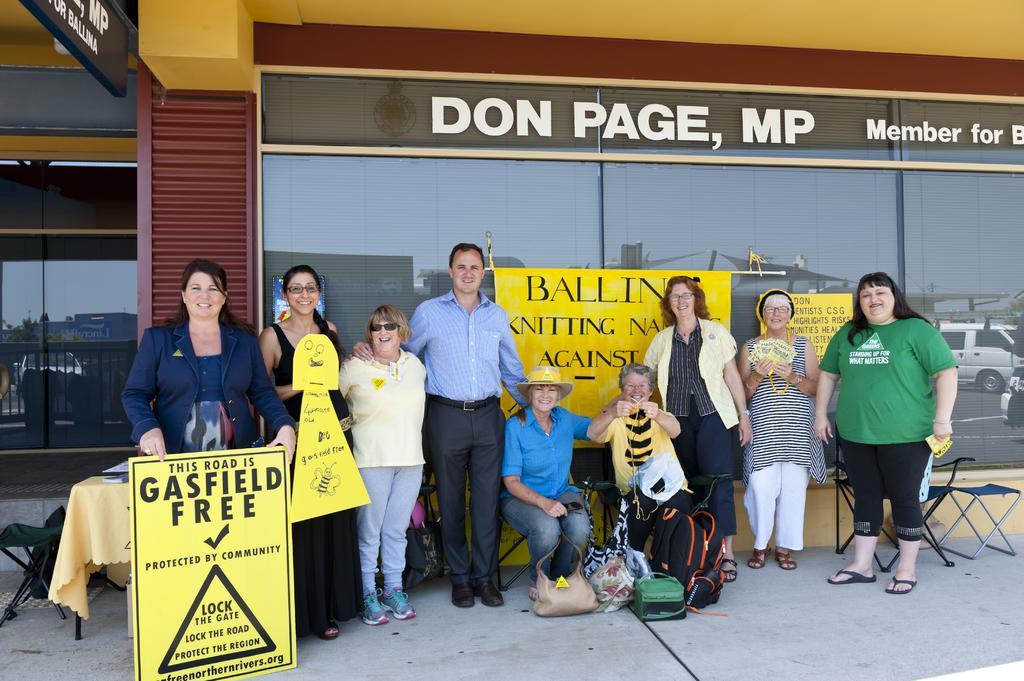Could you give a brief overview of what you see in this image? In this image we can see there are a few persons standing and holding papers and boards and there are two persons sitting on the chair. And at the side there are chairs. In front of the persons we can see the cover and bags. And at the back we can see the windows with text and there is the board attached to the wall. 